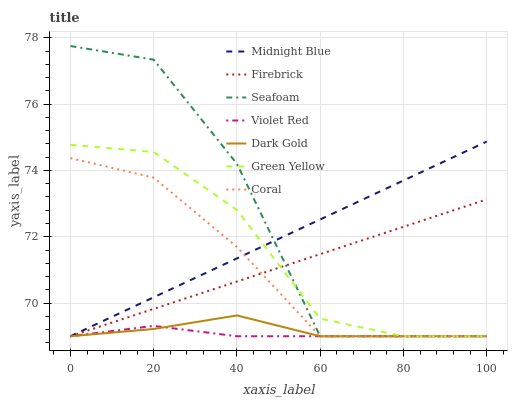Does Violet Red have the minimum area under the curve?
Answer yes or no. Yes. Does Midnight Blue have the minimum area under the curve?
Answer yes or no. No. Does Midnight Blue have the maximum area under the curve?
Answer yes or no. No. Is Dark Gold the smoothest?
Answer yes or no. No. Is Dark Gold the roughest?
Answer yes or no. No. Does Midnight Blue have the highest value?
Answer yes or no. No. 